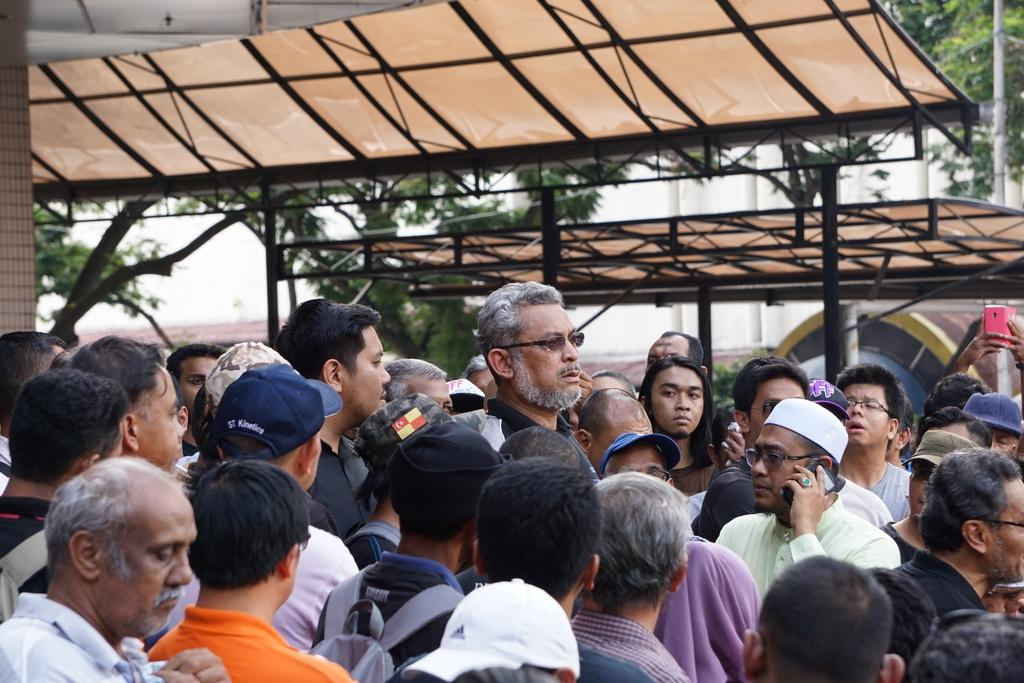What is the main subject in the foreground of the picture? There is a group of people in the foreground of the picture. What can be seen in the middle of the picture? There are sheds and trees in the middle of the picture. What is visible in the background of the picture? There are poles and a wall in the background of the picture. What type of juice is being served to the brothers in the picture? There are no brothers or juice present in the image. What type of pleasure can be seen on the faces of the people in the picture? The image does not show the facial expressions of the people, so it is not possible to determine if they are experiencing pleasure. 